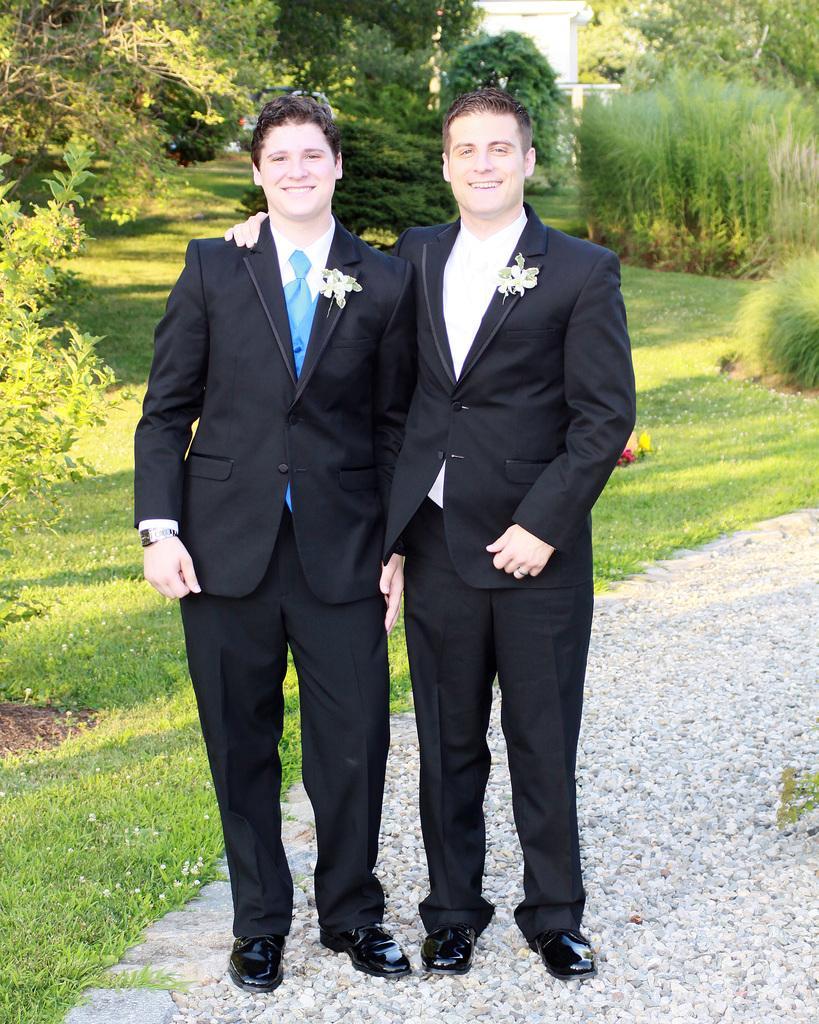Could you give a brief overview of what you see in this image? In this image, we can see two men are standing side by side on the walkway. They are watching and smiling. Here a person is holding another person. In the background, we can see plants, grass, trees and house. 